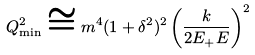Convert formula to latex. <formula><loc_0><loc_0><loc_500><loc_500>Q _ { \min } ^ { 2 } \cong m ^ { 4 } ( 1 + \delta ^ { 2 } ) ^ { 2 } \left ( \frac { k } { 2 E _ { + } E } \right ) ^ { 2 }</formula> 